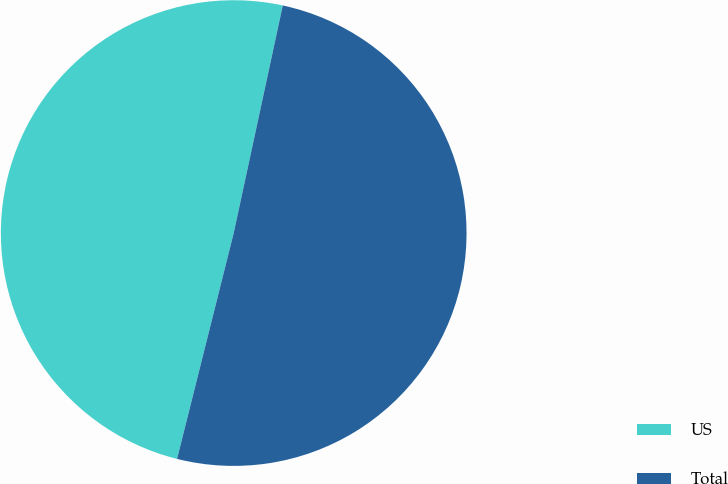Convert chart to OTSL. <chart><loc_0><loc_0><loc_500><loc_500><pie_chart><fcel>US<fcel>Total<nl><fcel>49.47%<fcel>50.53%<nl></chart> 